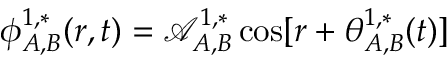<formula> <loc_0><loc_0><loc_500><loc_500>\phi _ { A , B } ^ { 1 , * } ( r , t ) = \mathcal { A } _ { A , B } ^ { 1 , * } \cos [ r + \theta _ { A , B } ^ { 1 , * } ( t ) ]</formula> 